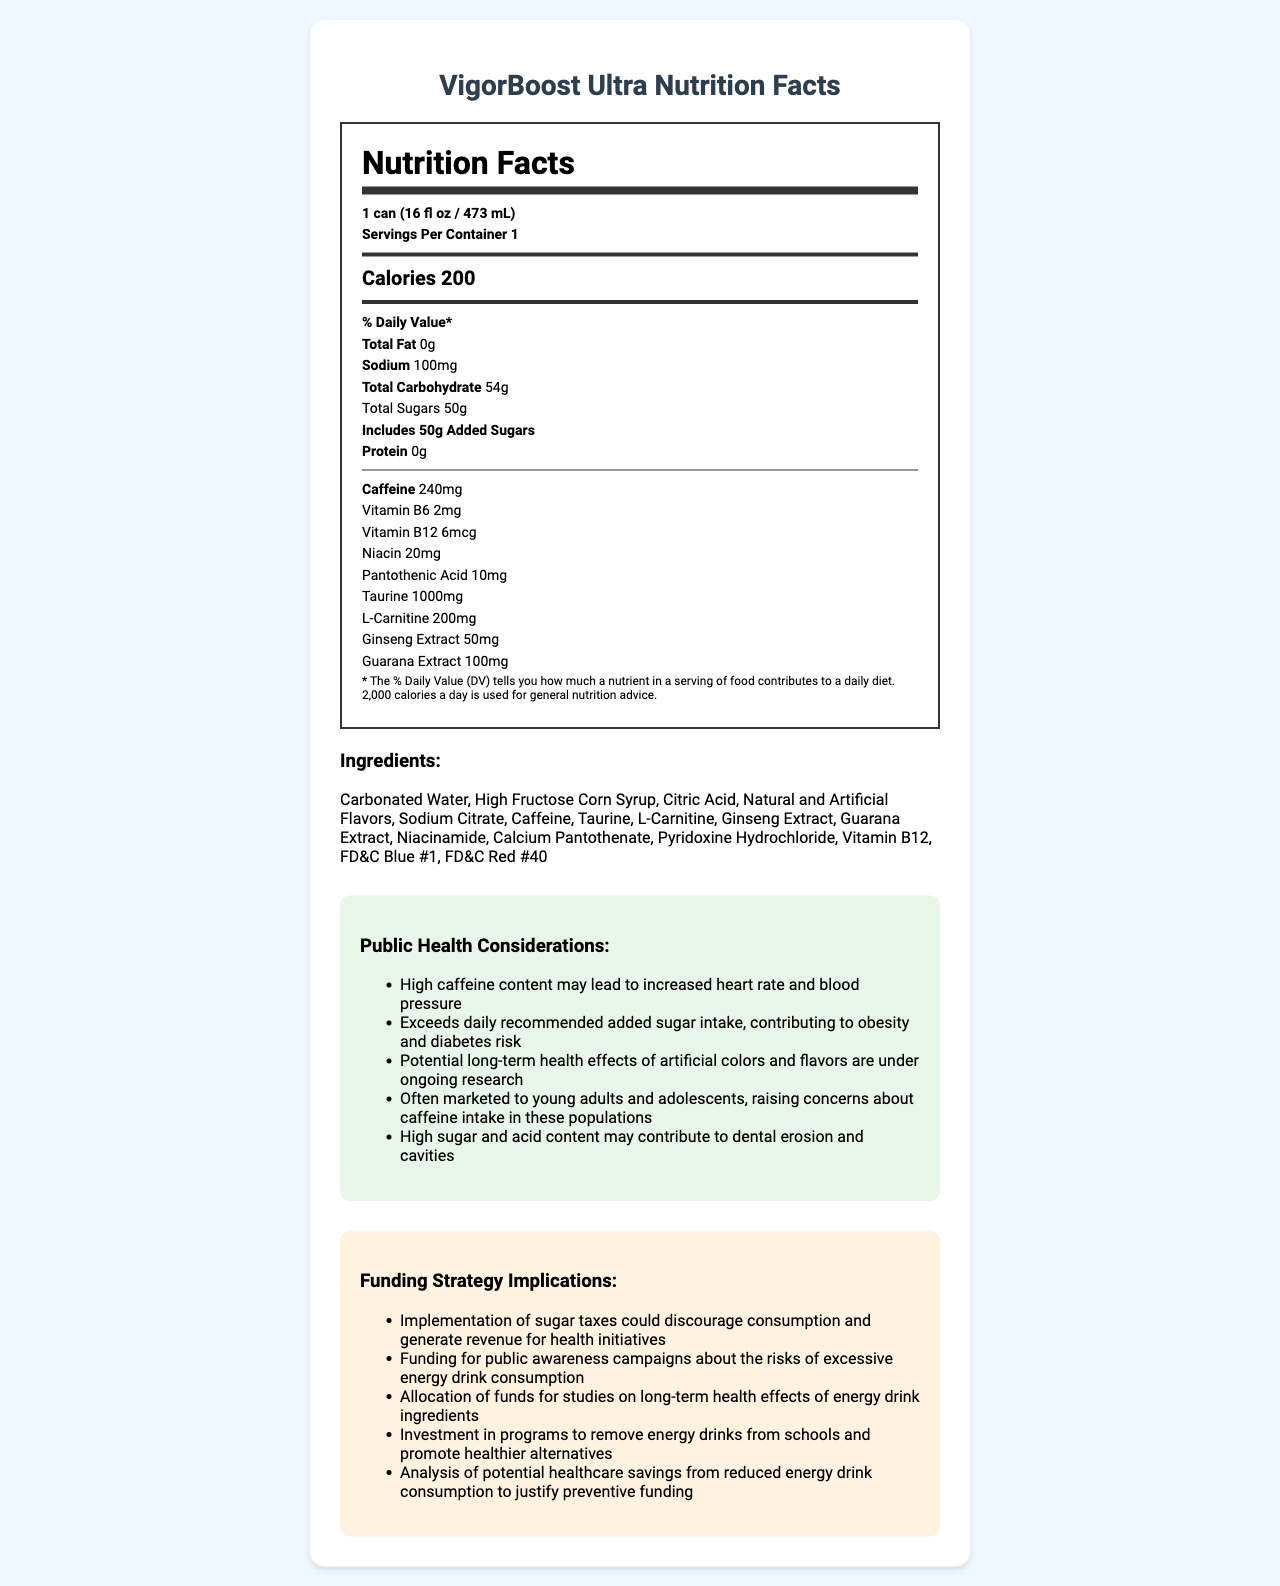what is the serving size? The serving size is clearly stated in the "Nutrition Facts" section at the very beginning.
Answer: 1 can (16 fl oz / 473 mL) how much caffeine is in one serving of VigorBoost Ultra? The caffeine content is listed under the nutrient information in the "Nutrition Facts" section.
Answer: 240mg how many grams of added sugars are in one can of VigorBoost Ultra? According to the "Nutrition Facts" section, the drink includes 50 grams of added sugars.
Answer: 50g how many servings are there per container? The "Nutrition Facts" section clearly states that there is 1 serving per container.
Answer: 1 how many calories are in one can of VigorBoost Ultra? This information is listed in the "Nutrition Facts" section under "Calories".
Answer: 200 calories which of the following is an ingredient in VigorBoost Ultra? A. Aspartame B. Sodium Citrate C. Sucralose D. Stevia The ingredients list includes Sodium Citrate but not Aspartame, Sucralose, or Stevia.
Answer: B. Sodium Citrate what are some public health considerations related to the product? These considerations are listed under the "Public Health Considerations" section in the document.
Answer: High caffeine content, exceeds daily recommended sugar intake, potential long-term health effects of artificial ingredients, marketing concerns for young adults, dental health risks why could implementing a sugar tax be beneficial? This is stated in the "Funding Strategy Implications" section under the sugar tax strategy.
Answer: It could discourage consumption and generate revenue for health initiatives. is there any protein in VigorBoost Ultra? The "Nutrition Facts" section indicates that there is 0g of protein in the drink.
Answer: No how much vitamin B6 is in one serving? The content of Vitamin B6 is listed in the "Nutrition Facts" section.
Answer: 2mg how is the product typically marketed, and why is this concerning from a public health perspective? The "Public Health Considerations" section notes these concerns about marketing to young people.
Answer: Often marketed to young adults and adolescents, raising concerns about their caffeine intake. what are the main ingredients related to energy boost mentioned in the product? These ingredients are listed in the "Ingredients" section and are commonly associated with energy-boosting effects.
Answer: Caffeine, Taurine, L-Carnitine, Ginseng Extract, Guarana Extract what is the risk associated with high sugar and acid content in the product? The "Public Health Considerations" section mentions that high sugar and acid content may contribute to these dental issues.
Answer: Dental erosion and cavities which funding strategy implication discusses the potential savings in healthcare costs? This is summarized in the "Funding Strategy Implications" section under "healthcare costs".
Answer: Healthcare savings from reduced energy drink consumption what is the main idea of the VigorBoost Ultra Nutrition Facts document? The document includes comprehensive nutrition facts, public health considerations, and various funding strategy implications to address the potential negative impacts of the energy drink.
Answer: The document provides detailed nutrition information, highlights public health considerations, and suggests funding strategy implications for a public health initiative related to the energy drink. 